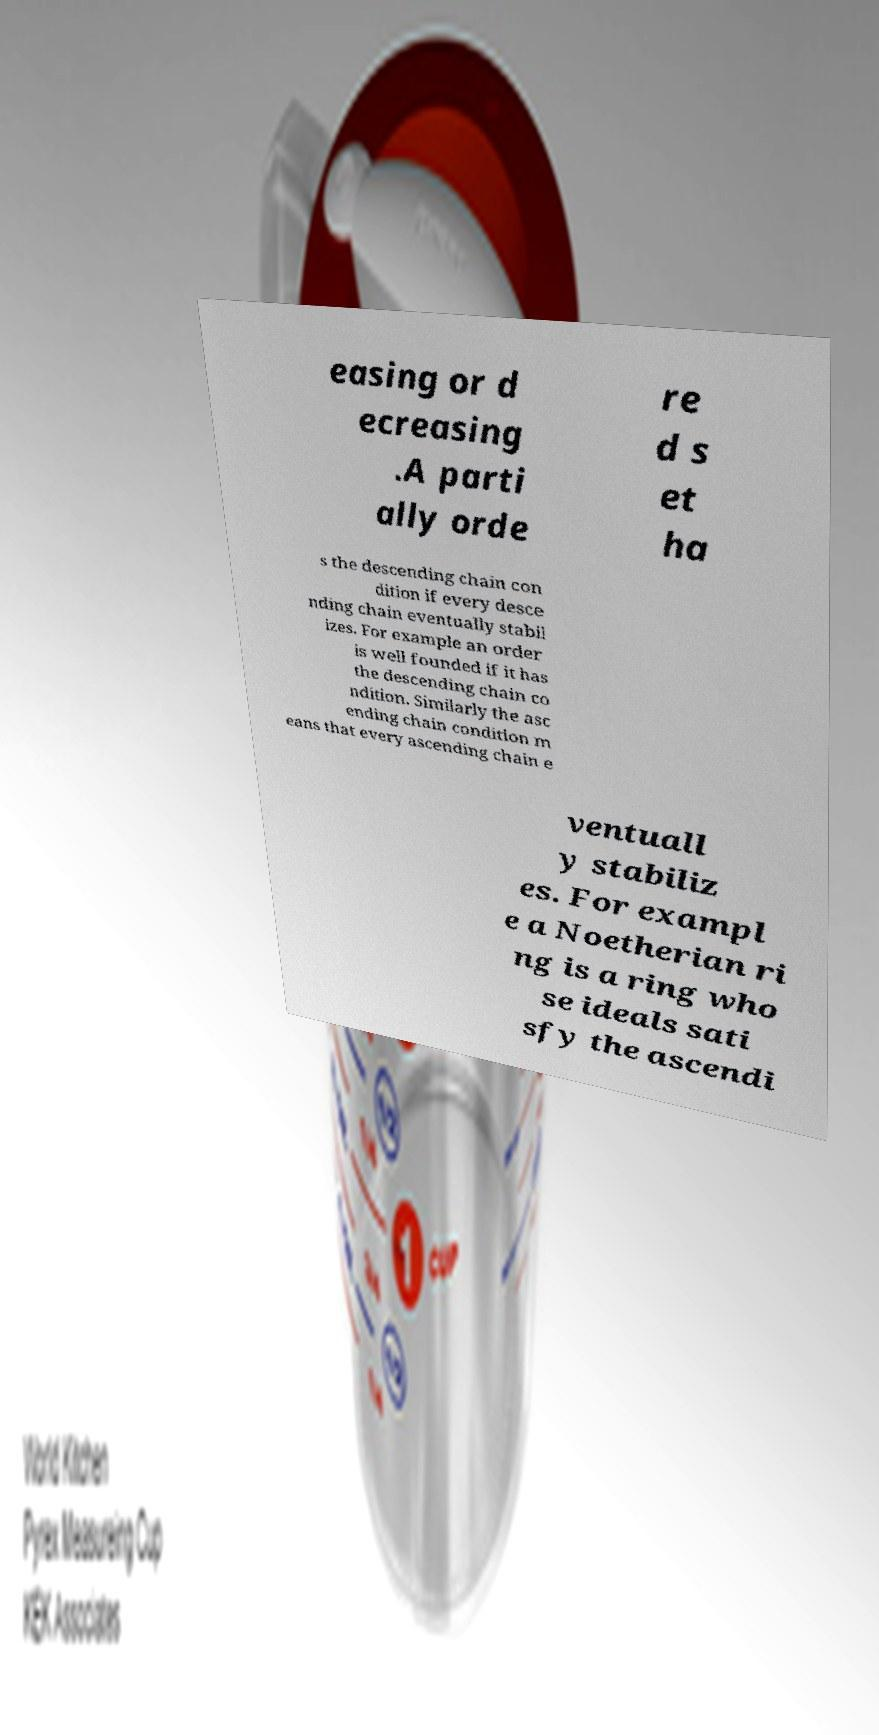Please read and relay the text visible in this image. What does it say? easing or d ecreasing .A parti ally orde re d s et ha s the descending chain con dition if every desce nding chain eventually stabil izes. For example an order is well founded if it has the descending chain co ndition. Similarly the asc ending chain condition m eans that every ascending chain e ventuall y stabiliz es. For exampl e a Noetherian ri ng is a ring who se ideals sati sfy the ascendi 